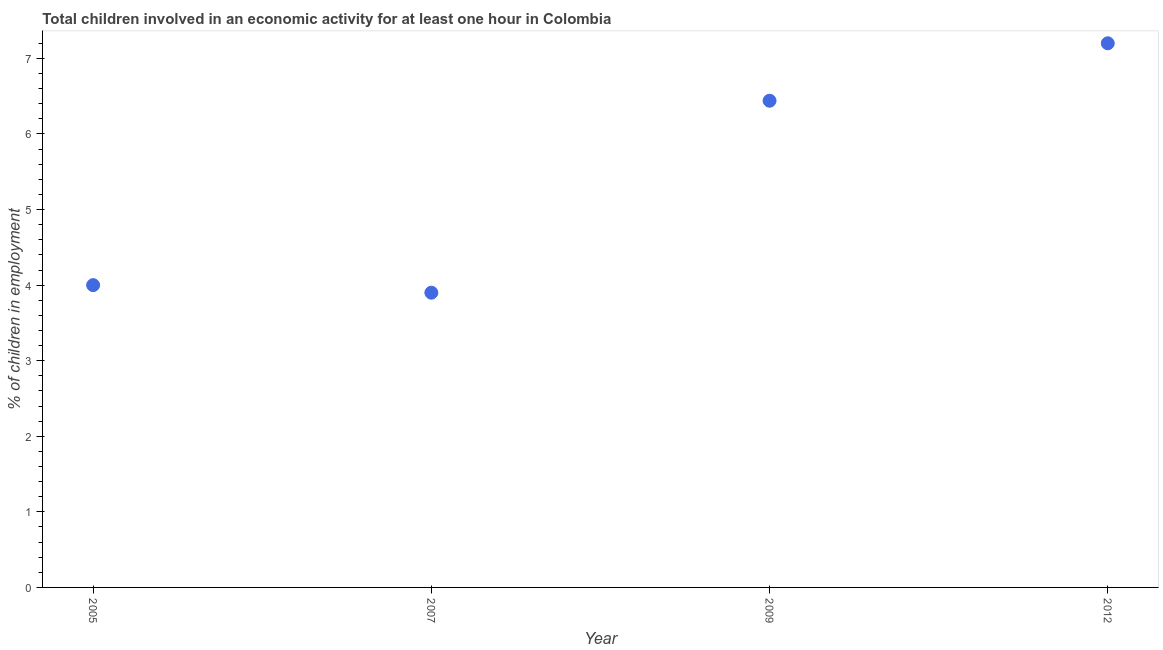What is the percentage of children in employment in 2009?
Give a very brief answer. 6.44. Across all years, what is the maximum percentage of children in employment?
Give a very brief answer. 7.2. Across all years, what is the minimum percentage of children in employment?
Your response must be concise. 3.9. What is the sum of the percentage of children in employment?
Provide a short and direct response. 21.54. What is the difference between the percentage of children in employment in 2007 and 2009?
Your answer should be very brief. -2.54. What is the average percentage of children in employment per year?
Your answer should be very brief. 5.38. What is the median percentage of children in employment?
Ensure brevity in your answer.  5.22. Do a majority of the years between 2007 and 2005 (inclusive) have percentage of children in employment greater than 0.6000000000000001 %?
Ensure brevity in your answer.  No. What is the ratio of the percentage of children in employment in 2007 to that in 2012?
Offer a very short reply. 0.54. Is the difference between the percentage of children in employment in 2005 and 2007 greater than the difference between any two years?
Keep it short and to the point. No. What is the difference between the highest and the second highest percentage of children in employment?
Keep it short and to the point. 0.76. Is the sum of the percentage of children in employment in 2007 and 2009 greater than the maximum percentage of children in employment across all years?
Provide a short and direct response. Yes. What is the difference between the highest and the lowest percentage of children in employment?
Keep it short and to the point. 3.3. In how many years, is the percentage of children in employment greater than the average percentage of children in employment taken over all years?
Provide a succinct answer. 2. How many years are there in the graph?
Give a very brief answer. 4. What is the difference between two consecutive major ticks on the Y-axis?
Provide a short and direct response. 1. Does the graph contain any zero values?
Provide a succinct answer. No. Does the graph contain grids?
Keep it short and to the point. No. What is the title of the graph?
Provide a succinct answer. Total children involved in an economic activity for at least one hour in Colombia. What is the label or title of the Y-axis?
Keep it short and to the point. % of children in employment. What is the % of children in employment in 2007?
Offer a very short reply. 3.9. What is the % of children in employment in 2009?
Make the answer very short. 6.44. What is the % of children in employment in 2012?
Provide a short and direct response. 7.2. What is the difference between the % of children in employment in 2005 and 2007?
Your answer should be very brief. 0.1. What is the difference between the % of children in employment in 2005 and 2009?
Your response must be concise. -2.44. What is the difference between the % of children in employment in 2007 and 2009?
Provide a short and direct response. -2.54. What is the difference between the % of children in employment in 2009 and 2012?
Offer a terse response. -0.76. What is the ratio of the % of children in employment in 2005 to that in 2007?
Your answer should be very brief. 1.03. What is the ratio of the % of children in employment in 2005 to that in 2009?
Your answer should be very brief. 0.62. What is the ratio of the % of children in employment in 2005 to that in 2012?
Offer a very short reply. 0.56. What is the ratio of the % of children in employment in 2007 to that in 2009?
Offer a very short reply. 0.61. What is the ratio of the % of children in employment in 2007 to that in 2012?
Give a very brief answer. 0.54. What is the ratio of the % of children in employment in 2009 to that in 2012?
Keep it short and to the point. 0.89. 